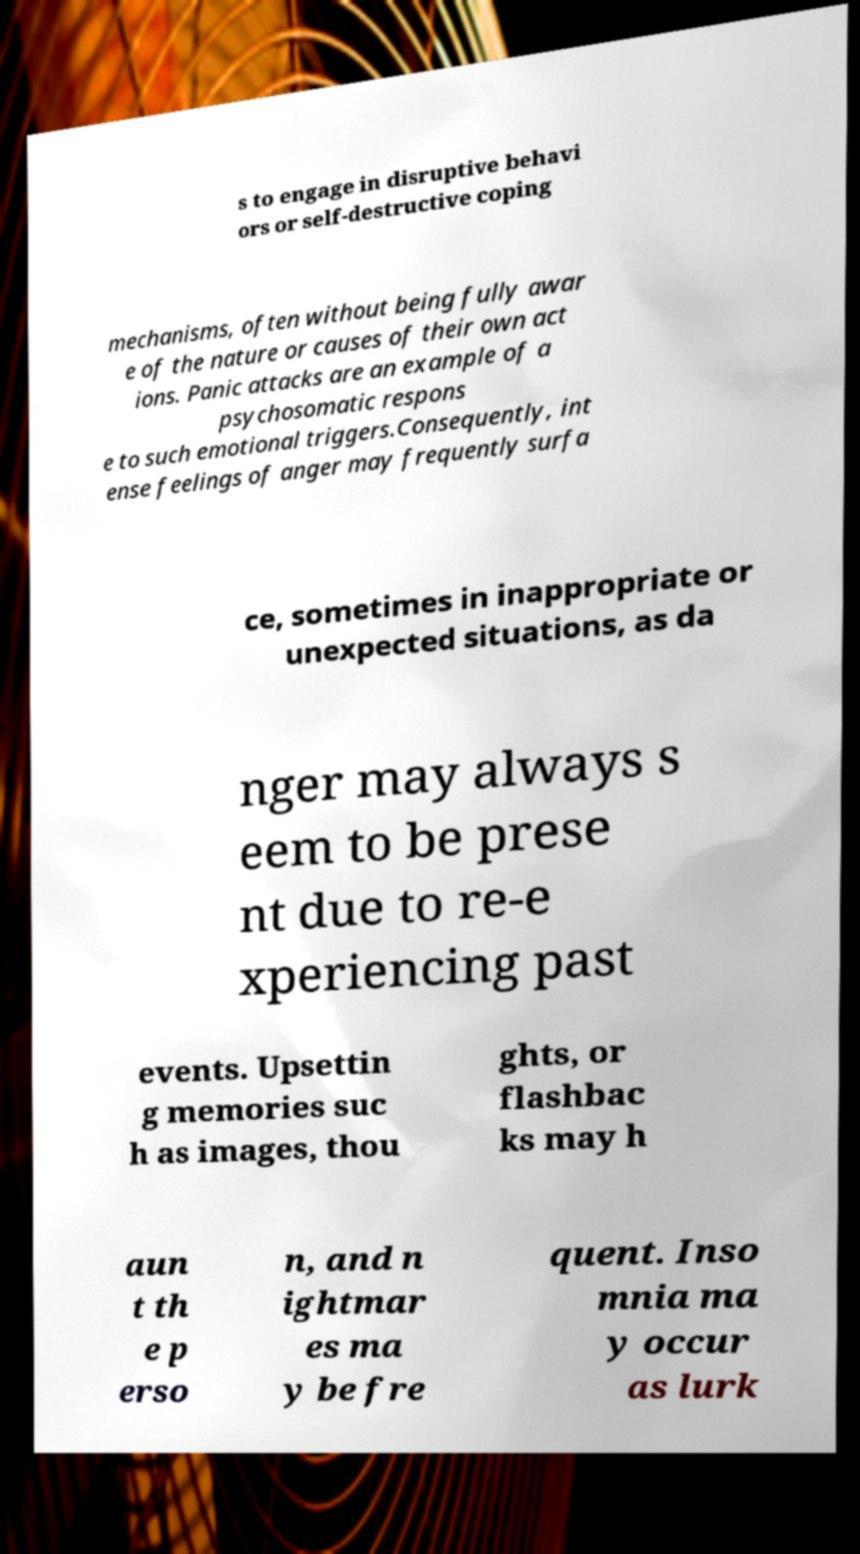Please read and relay the text visible in this image. What does it say? s to engage in disruptive behavi ors or self-destructive coping mechanisms, often without being fully awar e of the nature or causes of their own act ions. Panic attacks are an example of a psychosomatic respons e to such emotional triggers.Consequently, int ense feelings of anger may frequently surfa ce, sometimes in inappropriate or unexpected situations, as da nger may always s eem to be prese nt due to re-e xperiencing past events. Upsettin g memories suc h as images, thou ghts, or flashbac ks may h aun t th e p erso n, and n ightmar es ma y be fre quent. Inso mnia ma y occur as lurk 